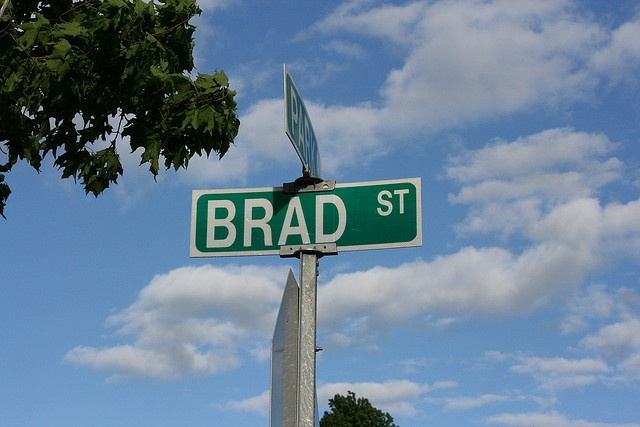Describe the objects in this image and their specific colors. I can see various objects in this image with different colors. 